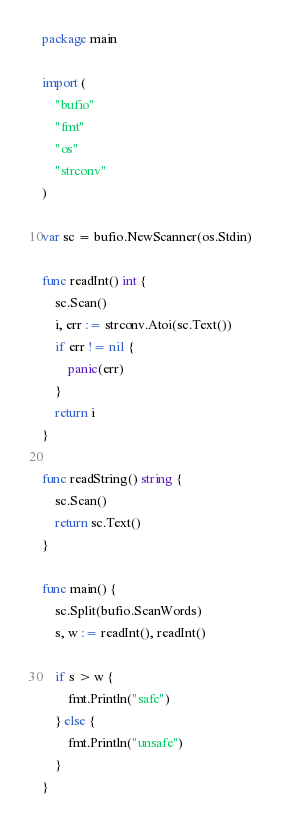Convert code to text. <code><loc_0><loc_0><loc_500><loc_500><_Go_>package main

import (
	"bufio"
	"fmt"
	"os"
	"strconv"
)

var sc = bufio.NewScanner(os.Stdin)

func readInt() int {
	sc.Scan()
	i, err := strconv.Atoi(sc.Text())
	if err != nil {
		panic(err)
	}
	return i
}

func readString() string {
	sc.Scan()
	return sc.Text()
}

func main() {
	sc.Split(bufio.ScanWords)
	s, w := readInt(), readInt()

	if s > w {
		fmt.Println("safe")
	} else {
		fmt.Println("unsafe")
	}
}
</code> 